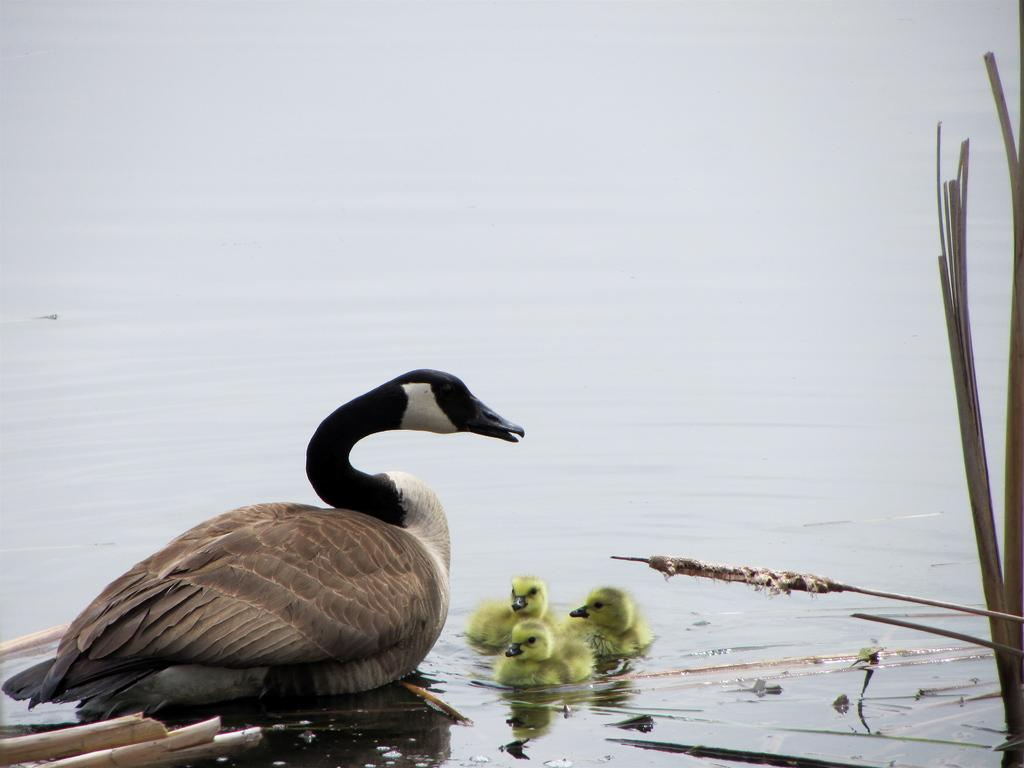What type of animal is the main subject in the image? There is a duck in the image. Are there any other animals present in the image? Yes, there are ducklings in the image. Where are the duck and ducklings located? The duck and ducklings are on the water. What else can be seen in the image besides the animals? There are plants visible in the image. What type of government is depicted in the image? There is no depiction of a government in the image; it features a duck, ducklings, and plants. Can you tell me how many geese are present in the image? There are no geese present in the image; it features a duck and ducklings. 